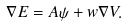Convert formula to latex. <formula><loc_0><loc_0><loc_500><loc_500>\nabla E = A \psi + w \nabla V .</formula> 